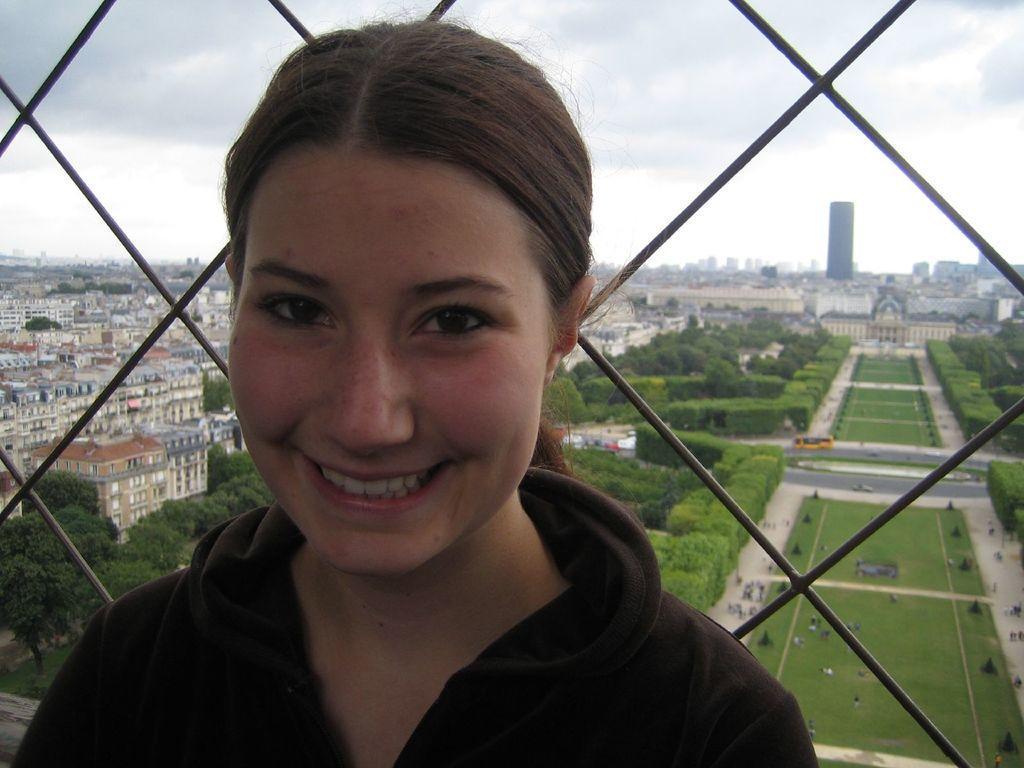Could you give a brief overview of what you see in this image? In this picture we can see a woman in the front, there are grills here, in the background we can see some buildings, trees, grass, there is sky at the top of the picture, we can see a bus here. 